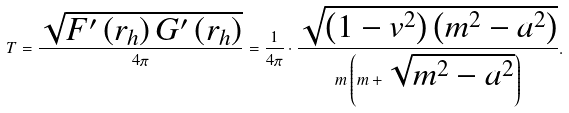<formula> <loc_0><loc_0><loc_500><loc_500>T = \frac { \sqrt { { F } ^ { \prime } \left ( { r _ { h } } \right ) { G } ^ { \prime } \left ( { r _ { h } } \right ) } } { 4 \pi } = \frac { 1 } { 4 \pi } \cdot \frac { \sqrt { \left ( { 1 - v ^ { 2 } } \right ) \left ( { m ^ { 2 } - a ^ { 2 } } \right ) } } { m \left ( { m + \sqrt { m ^ { 2 } - a ^ { 2 } } } \right ) } .</formula> 